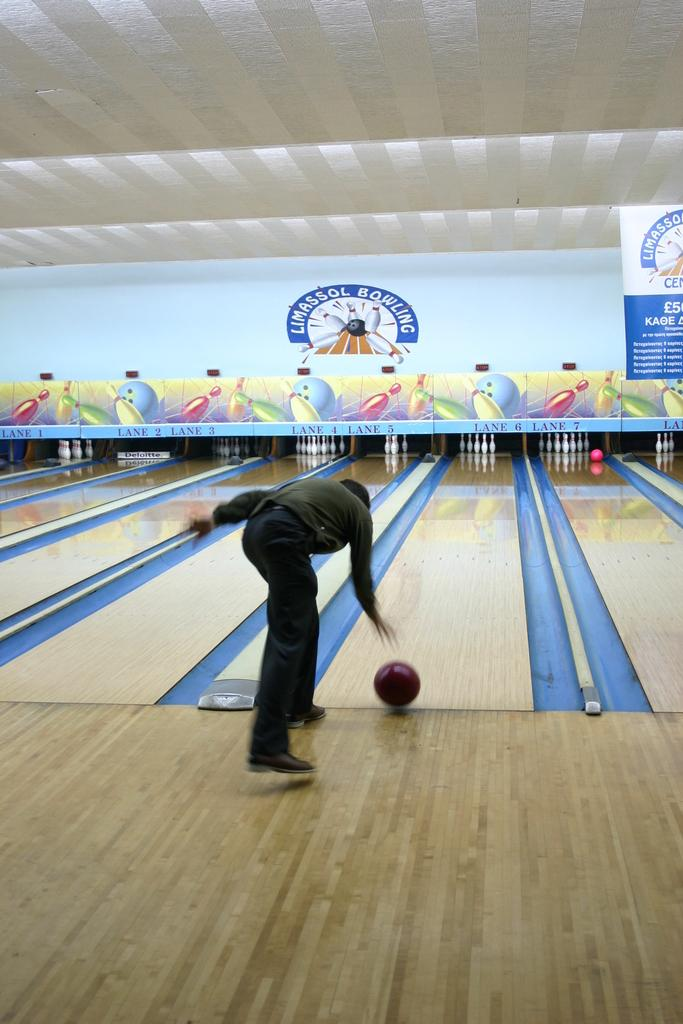What activity is taking place in the image? There is a ten pin bowling game in the image. Can you describe the person in the image? A person is present in the foreground of the image. What is the person doing in the image? The person is throwing a ball. How many spiders are crawling on the bowling ball in the image? There are no spiders present in the image; the focus is on the person throwing the bowling ball. What type of sand can be seen on the bowling lane in the image? There is no sand visible on the bowling lane in the image. 